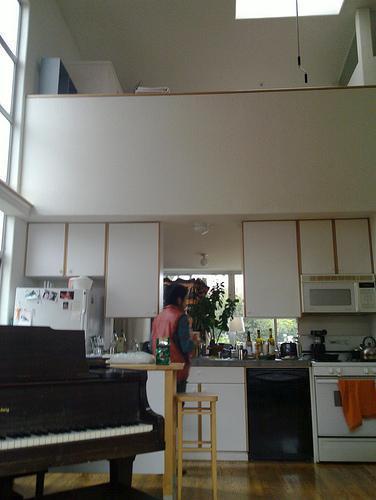How many people are shown?
Give a very brief answer. 1. 